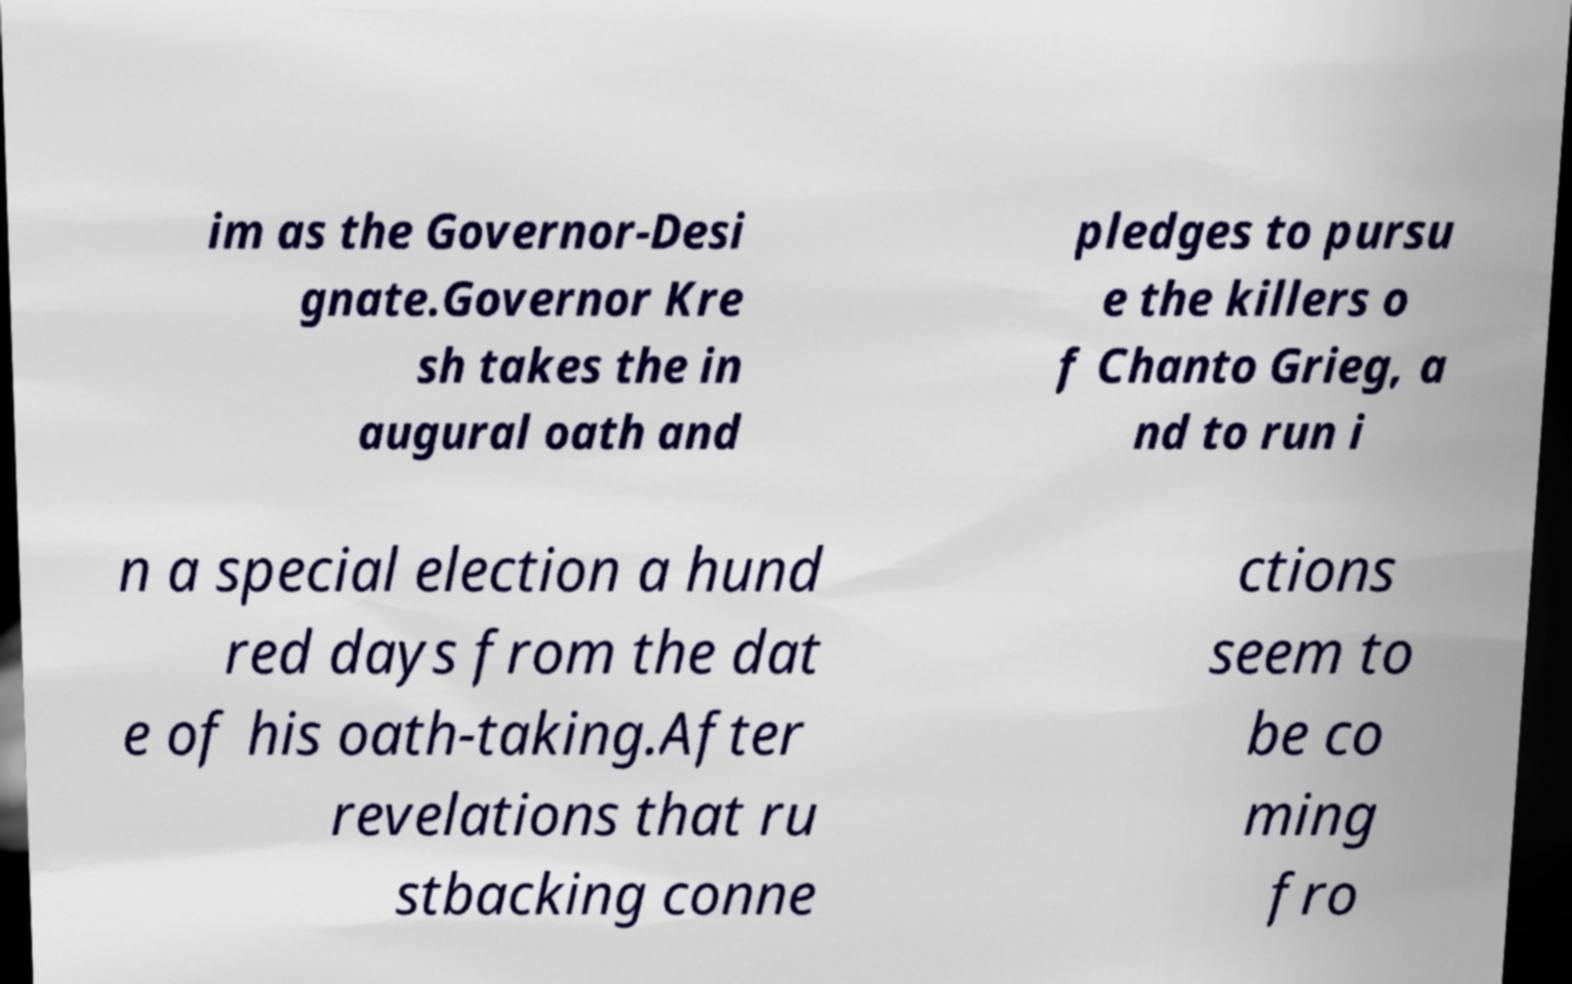Please identify and transcribe the text found in this image. im as the Governor-Desi gnate.Governor Kre sh takes the in augural oath and pledges to pursu e the killers o f Chanto Grieg, a nd to run i n a special election a hund red days from the dat e of his oath-taking.After revelations that ru stbacking conne ctions seem to be co ming fro 